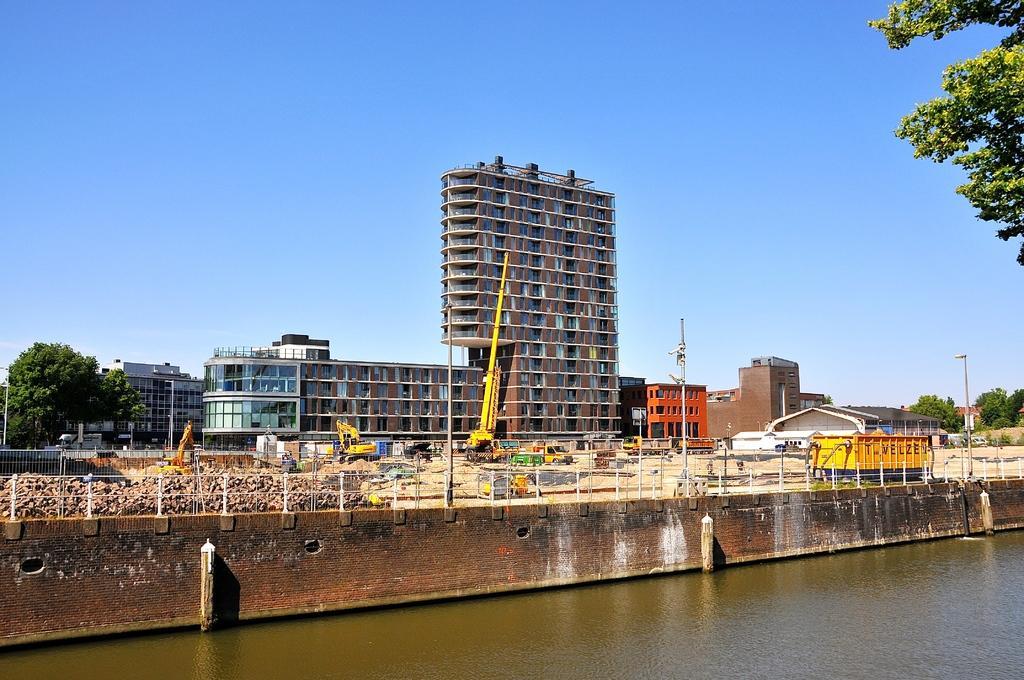Could you give a brief overview of what you see in this image? In this image in the center there are buildings. In front of the building there are cranes and there are vehicles moving on the road. There is a tree on the left side and in the front there is water. On the right side there are trees. 